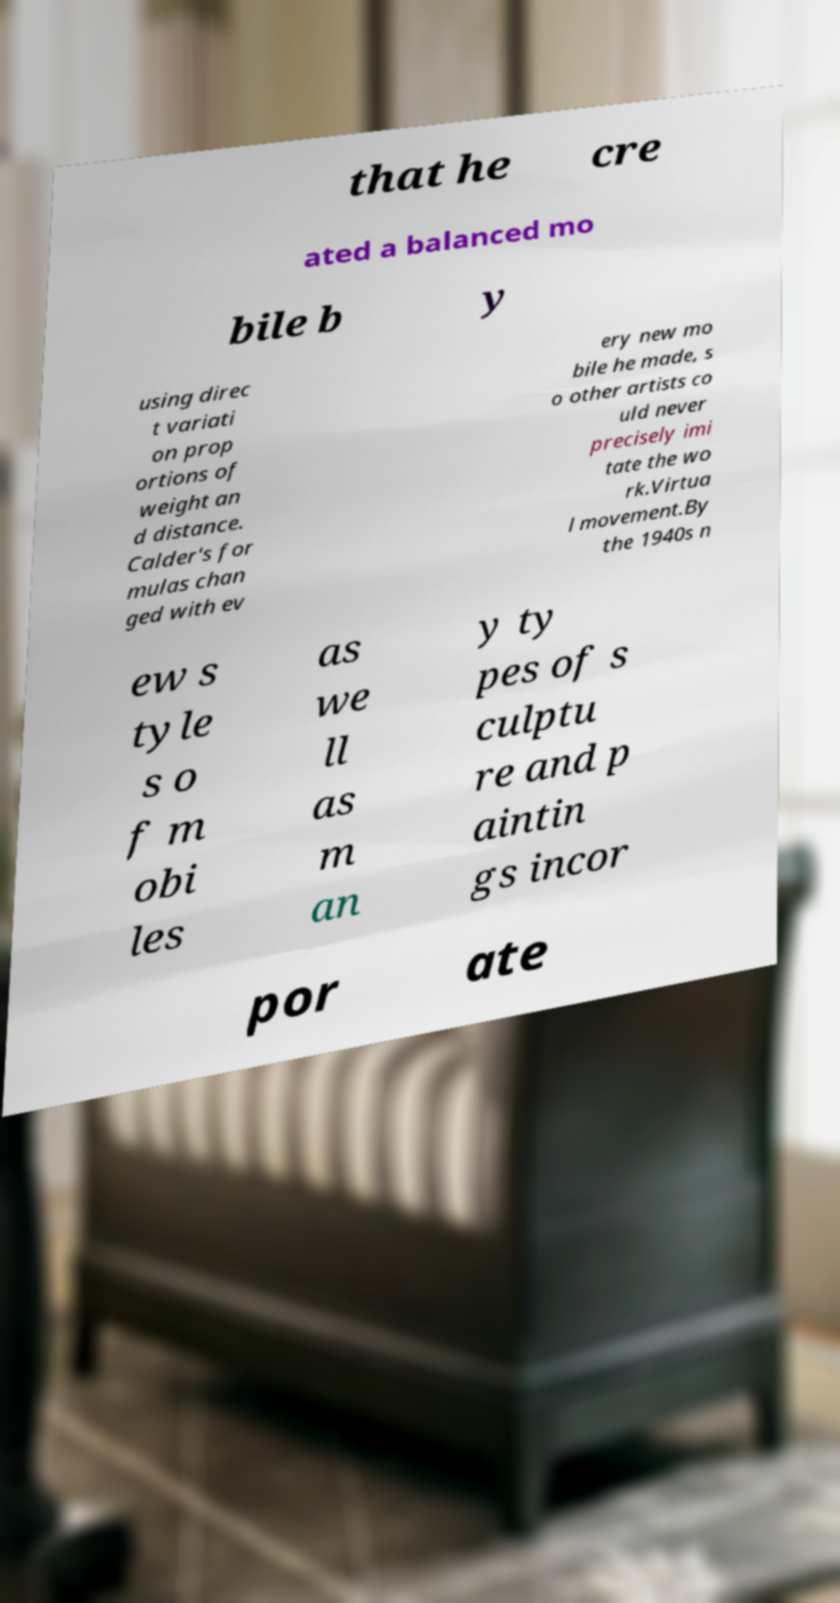For documentation purposes, I need the text within this image transcribed. Could you provide that? that he cre ated a balanced mo bile b y using direc t variati on prop ortions of weight an d distance. Calder's for mulas chan ged with ev ery new mo bile he made, s o other artists co uld never precisely imi tate the wo rk.Virtua l movement.By the 1940s n ew s tyle s o f m obi les as we ll as m an y ty pes of s culptu re and p aintin gs incor por ate 